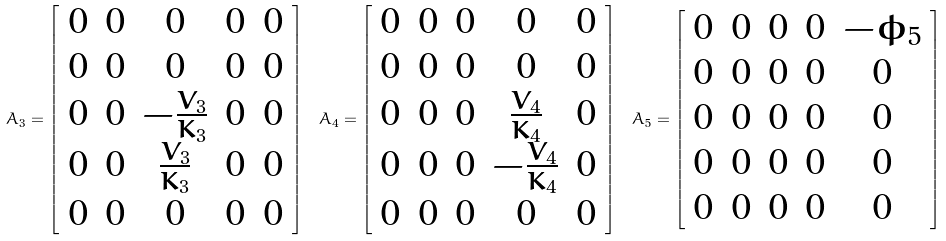Convert formula to latex. <formula><loc_0><loc_0><loc_500><loc_500>A _ { 3 } = \left [ \begin{array} { c c c c c } 0 & 0 & 0 & 0 & 0 \\ 0 & 0 & 0 & 0 & 0 \\ 0 & 0 & - \frac { V _ { 3 } } { K _ { 3 } } & 0 & 0 \\ 0 & 0 & \frac { V _ { 3 } } { K _ { 3 } } & 0 & 0 \\ 0 & 0 & 0 & 0 & 0 \end{array} \right ] \ A _ { 4 } = \left [ \begin{array} { c c c c c } 0 & 0 & 0 & 0 & 0 \\ 0 & 0 & 0 & 0 & 0 \\ 0 & 0 & 0 & \frac { V _ { 4 } } { K _ { 4 } } & 0 \\ 0 & 0 & 0 & - \frac { V _ { 4 } } { K _ { 4 } } & 0 \\ 0 & 0 & 0 & 0 & 0 \end{array} \right ] \ A _ { 5 } = \left [ \begin{array} { c c c c c } 0 & 0 & 0 & 0 & - \bar { \phi } _ { 5 } \\ 0 & 0 & 0 & 0 & 0 \\ 0 & 0 & 0 & 0 & 0 \\ 0 & 0 & 0 & 0 & 0 \\ 0 & 0 & 0 & 0 & 0 \end{array} \right ]</formula> 